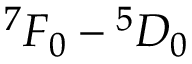Convert formula to latex. <formula><loc_0><loc_0><loc_500><loc_500>{ } ^ { 7 } F _ { 0 } ^ { 5 } D _ { 0 }</formula> 